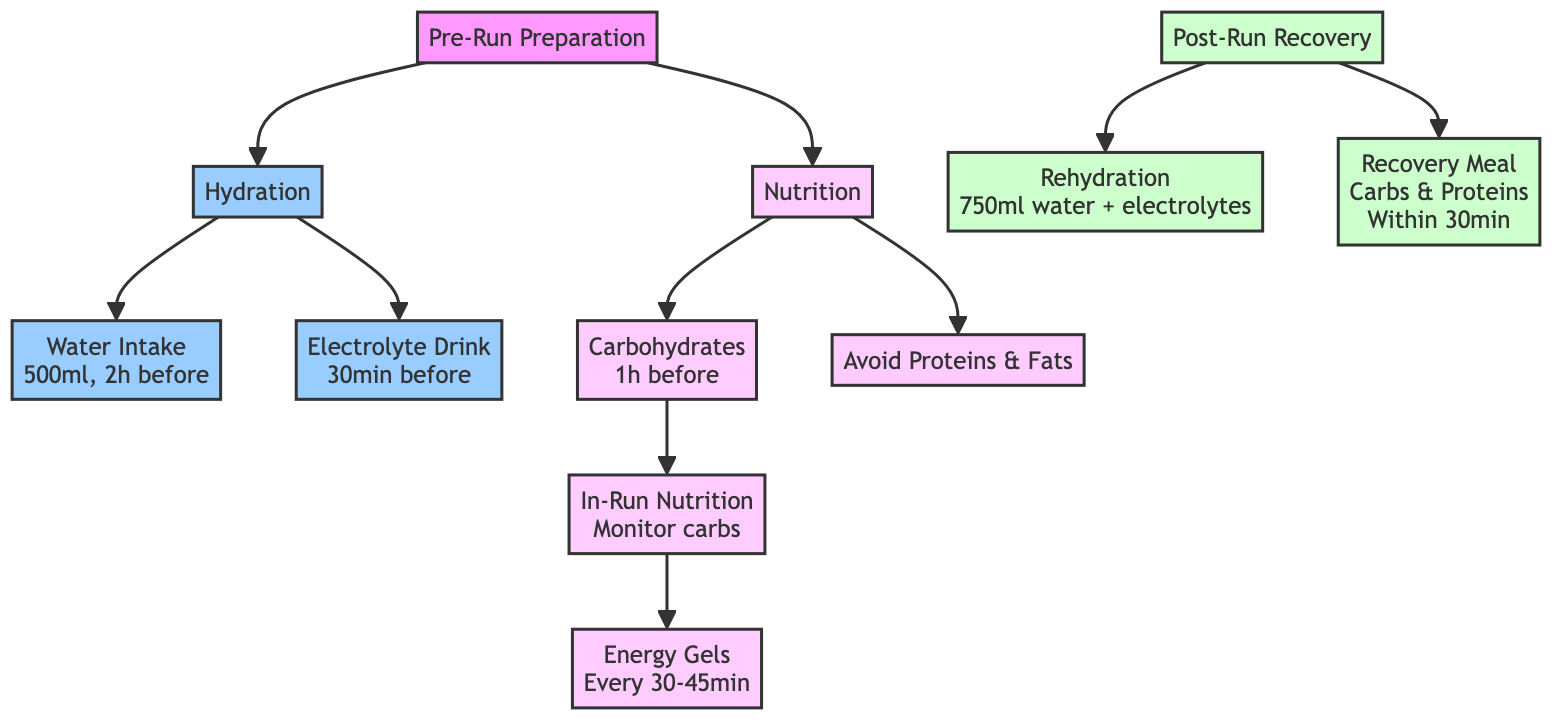What are the two main categories of preparation before a run? The diagram shows "Hydration" and "Nutrition" as two nodes branching from "Pre-Run Preparation."
Answer: Hydration, Nutrition How many elements are listed under "Hydration"? In the diagram, "Hydration" has two children: "Water Intake" and "Electrolyte Drink," indicating a total of two elements.
Answer: 2 What should you consume 1 hour before running? The diagram specifies that "Carbohydrates," such as a banana or energy bar, should be eaten 1 hour before running.
Answer: Carbohydrates What is the recommended water intake before running? According to the diagram, it is suggested to drink 500ml of water 2 hours before running, specified under the node "Water Intake."
Answer: 500ml What is the relationship between "In-Run Nutrition" and "Energy Gels"? The diagram shows that "In-Run Nutrition" leads to "Energy Gels," meaning that monitoring carbohydrates during the run relates to consuming gels.
Answer: Leads to What should be avoided before running? The diagram indicates avoiding "heavy proteins and fats" under the "Proteins and Fats" node, which is crucial for pre-run preparation.
Answer: Heavy proteins and fats How soon after a run should you eat your recovery meal? The diagram states that the recovery meal, rich in carbohydrates and proteins, should be consumed within 30 minutes post-run, as specified under the "Recovery Meal" node.
Answer: Within 30 minutes What type of drink is recommended immediately post-run? The diagram clearly states that "Rehydration" involves drinking 750ml of water mixed with electrolytes immediately after the run.
Answer: 750ml water + electrolytes What is the first step in the hydration process? The diagram shows that the first step in hydration before running is "Water Intake," which involves drinking 500ml of water 2 hours prior to running.
Answer: Water Intake 